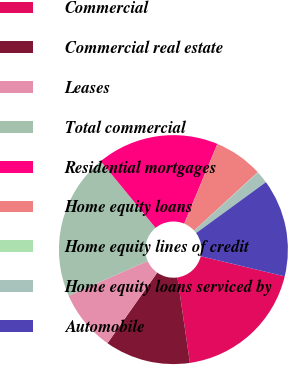<chart> <loc_0><loc_0><loc_500><loc_500><pie_chart><fcel>Commercial<fcel>Commercial real estate<fcel>Leases<fcel>Total commercial<fcel>Residential mortgages<fcel>Home equity loans<fcel>Home equity lines of credit<fcel>Home equity loans serviced by<fcel>Automobile<nl><fcel>18.94%<fcel>12.07%<fcel>8.63%<fcel>20.66%<fcel>17.22%<fcel>6.91%<fcel>0.04%<fcel>1.75%<fcel>13.78%<nl></chart> 